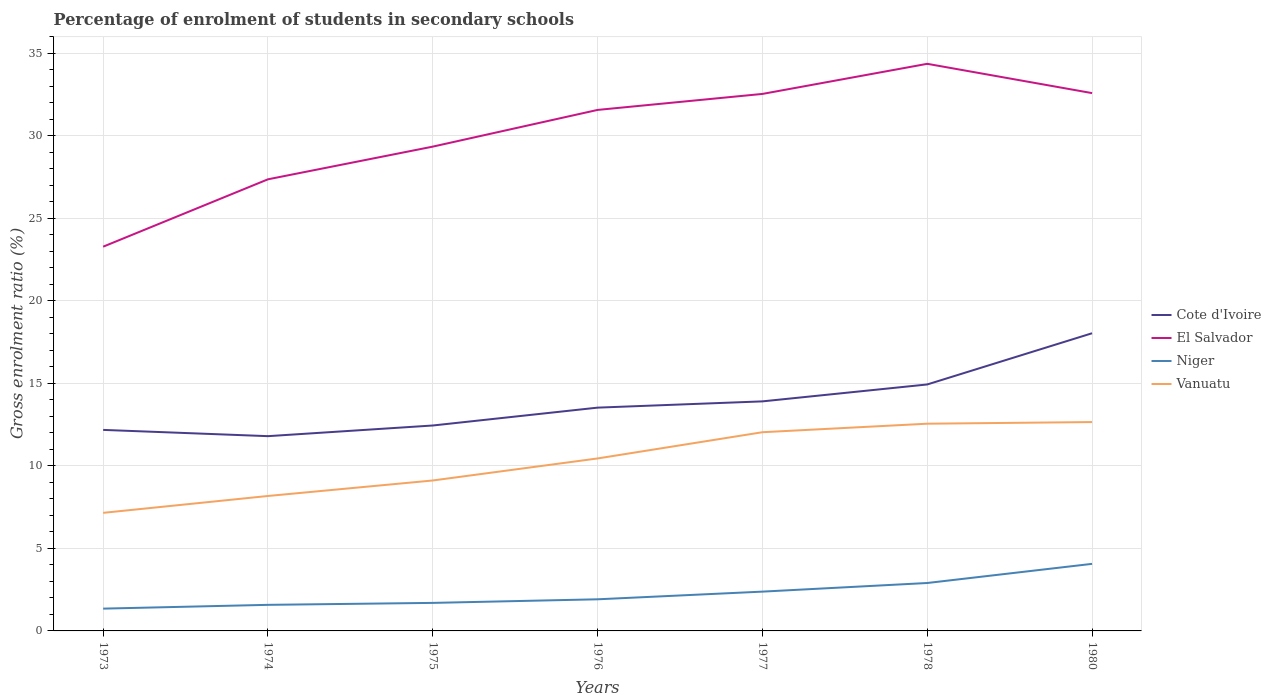How many different coloured lines are there?
Your response must be concise. 4. Is the number of lines equal to the number of legend labels?
Keep it short and to the point. Yes. Across all years, what is the maximum percentage of students enrolled in secondary schools in Vanuatu?
Your response must be concise. 7.16. In which year was the percentage of students enrolled in secondary schools in El Salvador maximum?
Make the answer very short. 1973. What is the total percentage of students enrolled in secondary schools in Niger in the graph?
Give a very brief answer. -0.57. What is the difference between the highest and the second highest percentage of students enrolled in secondary schools in Cote d'Ivoire?
Your response must be concise. 6.24. Is the percentage of students enrolled in secondary schools in Vanuatu strictly greater than the percentage of students enrolled in secondary schools in El Salvador over the years?
Your answer should be compact. Yes. Does the graph contain any zero values?
Your response must be concise. No. Does the graph contain grids?
Ensure brevity in your answer.  Yes. Where does the legend appear in the graph?
Keep it short and to the point. Center right. How many legend labels are there?
Make the answer very short. 4. How are the legend labels stacked?
Your answer should be very brief. Vertical. What is the title of the graph?
Give a very brief answer. Percentage of enrolment of students in secondary schools. Does "Northern Mariana Islands" appear as one of the legend labels in the graph?
Give a very brief answer. No. What is the Gross enrolment ratio (%) in Cote d'Ivoire in 1973?
Ensure brevity in your answer.  12.18. What is the Gross enrolment ratio (%) of El Salvador in 1973?
Give a very brief answer. 23.28. What is the Gross enrolment ratio (%) in Niger in 1973?
Give a very brief answer. 1.35. What is the Gross enrolment ratio (%) in Vanuatu in 1973?
Your response must be concise. 7.16. What is the Gross enrolment ratio (%) of Cote d'Ivoire in 1974?
Offer a terse response. 11.8. What is the Gross enrolment ratio (%) of El Salvador in 1974?
Your answer should be compact. 27.37. What is the Gross enrolment ratio (%) in Niger in 1974?
Ensure brevity in your answer.  1.58. What is the Gross enrolment ratio (%) of Vanuatu in 1974?
Your response must be concise. 8.18. What is the Gross enrolment ratio (%) in Cote d'Ivoire in 1975?
Your answer should be very brief. 12.45. What is the Gross enrolment ratio (%) of El Salvador in 1975?
Give a very brief answer. 29.35. What is the Gross enrolment ratio (%) of Niger in 1975?
Give a very brief answer. 1.7. What is the Gross enrolment ratio (%) in Vanuatu in 1975?
Your response must be concise. 9.12. What is the Gross enrolment ratio (%) of Cote d'Ivoire in 1976?
Provide a short and direct response. 13.53. What is the Gross enrolment ratio (%) in El Salvador in 1976?
Your response must be concise. 31.57. What is the Gross enrolment ratio (%) of Niger in 1976?
Provide a short and direct response. 1.92. What is the Gross enrolment ratio (%) of Vanuatu in 1976?
Your response must be concise. 10.45. What is the Gross enrolment ratio (%) in Cote d'Ivoire in 1977?
Offer a terse response. 13.91. What is the Gross enrolment ratio (%) of El Salvador in 1977?
Your answer should be very brief. 32.54. What is the Gross enrolment ratio (%) of Niger in 1977?
Offer a terse response. 2.38. What is the Gross enrolment ratio (%) of Vanuatu in 1977?
Your answer should be compact. 12.04. What is the Gross enrolment ratio (%) in Cote d'Ivoire in 1978?
Offer a terse response. 14.93. What is the Gross enrolment ratio (%) of El Salvador in 1978?
Ensure brevity in your answer.  34.36. What is the Gross enrolment ratio (%) in Niger in 1978?
Offer a very short reply. 2.9. What is the Gross enrolment ratio (%) in Vanuatu in 1978?
Provide a short and direct response. 12.56. What is the Gross enrolment ratio (%) in Cote d'Ivoire in 1980?
Offer a terse response. 18.04. What is the Gross enrolment ratio (%) in El Salvador in 1980?
Offer a terse response. 32.59. What is the Gross enrolment ratio (%) of Niger in 1980?
Your answer should be very brief. 4.06. What is the Gross enrolment ratio (%) of Vanuatu in 1980?
Your response must be concise. 12.66. Across all years, what is the maximum Gross enrolment ratio (%) of Cote d'Ivoire?
Offer a very short reply. 18.04. Across all years, what is the maximum Gross enrolment ratio (%) of El Salvador?
Your answer should be very brief. 34.36. Across all years, what is the maximum Gross enrolment ratio (%) in Niger?
Keep it short and to the point. 4.06. Across all years, what is the maximum Gross enrolment ratio (%) of Vanuatu?
Offer a very short reply. 12.66. Across all years, what is the minimum Gross enrolment ratio (%) in Cote d'Ivoire?
Make the answer very short. 11.8. Across all years, what is the minimum Gross enrolment ratio (%) of El Salvador?
Provide a short and direct response. 23.28. Across all years, what is the minimum Gross enrolment ratio (%) of Niger?
Provide a short and direct response. 1.35. Across all years, what is the minimum Gross enrolment ratio (%) in Vanuatu?
Give a very brief answer. 7.16. What is the total Gross enrolment ratio (%) of Cote d'Ivoire in the graph?
Give a very brief answer. 96.84. What is the total Gross enrolment ratio (%) of El Salvador in the graph?
Make the answer very short. 211.06. What is the total Gross enrolment ratio (%) of Niger in the graph?
Offer a very short reply. 15.9. What is the total Gross enrolment ratio (%) of Vanuatu in the graph?
Offer a very short reply. 72.15. What is the difference between the Gross enrolment ratio (%) in Cote d'Ivoire in 1973 and that in 1974?
Make the answer very short. 0.38. What is the difference between the Gross enrolment ratio (%) in El Salvador in 1973 and that in 1974?
Your answer should be compact. -4.08. What is the difference between the Gross enrolment ratio (%) of Niger in 1973 and that in 1974?
Make the answer very short. -0.23. What is the difference between the Gross enrolment ratio (%) in Vanuatu in 1973 and that in 1974?
Your answer should be very brief. -1.02. What is the difference between the Gross enrolment ratio (%) in Cote d'Ivoire in 1973 and that in 1975?
Make the answer very short. -0.27. What is the difference between the Gross enrolment ratio (%) of El Salvador in 1973 and that in 1975?
Your answer should be compact. -6.06. What is the difference between the Gross enrolment ratio (%) of Niger in 1973 and that in 1975?
Make the answer very short. -0.35. What is the difference between the Gross enrolment ratio (%) in Vanuatu in 1973 and that in 1975?
Provide a succinct answer. -1.96. What is the difference between the Gross enrolment ratio (%) in Cote d'Ivoire in 1973 and that in 1976?
Make the answer very short. -1.35. What is the difference between the Gross enrolment ratio (%) of El Salvador in 1973 and that in 1976?
Provide a short and direct response. -8.29. What is the difference between the Gross enrolment ratio (%) in Niger in 1973 and that in 1976?
Your response must be concise. -0.57. What is the difference between the Gross enrolment ratio (%) of Vanuatu in 1973 and that in 1976?
Give a very brief answer. -3.3. What is the difference between the Gross enrolment ratio (%) of Cote d'Ivoire in 1973 and that in 1977?
Keep it short and to the point. -1.73. What is the difference between the Gross enrolment ratio (%) in El Salvador in 1973 and that in 1977?
Offer a terse response. -9.26. What is the difference between the Gross enrolment ratio (%) of Niger in 1973 and that in 1977?
Your answer should be compact. -1.03. What is the difference between the Gross enrolment ratio (%) of Vanuatu in 1973 and that in 1977?
Offer a terse response. -4.88. What is the difference between the Gross enrolment ratio (%) of Cote d'Ivoire in 1973 and that in 1978?
Your answer should be compact. -2.75. What is the difference between the Gross enrolment ratio (%) of El Salvador in 1973 and that in 1978?
Your response must be concise. -11.08. What is the difference between the Gross enrolment ratio (%) in Niger in 1973 and that in 1978?
Your response must be concise. -1.55. What is the difference between the Gross enrolment ratio (%) in Vanuatu in 1973 and that in 1978?
Your response must be concise. -5.4. What is the difference between the Gross enrolment ratio (%) in Cote d'Ivoire in 1973 and that in 1980?
Keep it short and to the point. -5.86. What is the difference between the Gross enrolment ratio (%) of El Salvador in 1973 and that in 1980?
Your answer should be compact. -9.31. What is the difference between the Gross enrolment ratio (%) in Niger in 1973 and that in 1980?
Your response must be concise. -2.71. What is the difference between the Gross enrolment ratio (%) of Vanuatu in 1973 and that in 1980?
Offer a very short reply. -5.5. What is the difference between the Gross enrolment ratio (%) of Cote d'Ivoire in 1974 and that in 1975?
Keep it short and to the point. -0.65. What is the difference between the Gross enrolment ratio (%) of El Salvador in 1974 and that in 1975?
Your answer should be very brief. -1.98. What is the difference between the Gross enrolment ratio (%) of Niger in 1974 and that in 1975?
Keep it short and to the point. -0.12. What is the difference between the Gross enrolment ratio (%) of Vanuatu in 1974 and that in 1975?
Your answer should be very brief. -0.94. What is the difference between the Gross enrolment ratio (%) in Cote d'Ivoire in 1974 and that in 1976?
Offer a terse response. -1.73. What is the difference between the Gross enrolment ratio (%) in El Salvador in 1974 and that in 1976?
Offer a terse response. -4.2. What is the difference between the Gross enrolment ratio (%) of Niger in 1974 and that in 1976?
Provide a succinct answer. -0.34. What is the difference between the Gross enrolment ratio (%) of Vanuatu in 1974 and that in 1976?
Provide a short and direct response. -2.27. What is the difference between the Gross enrolment ratio (%) of Cote d'Ivoire in 1974 and that in 1977?
Keep it short and to the point. -2.11. What is the difference between the Gross enrolment ratio (%) in El Salvador in 1974 and that in 1977?
Provide a short and direct response. -5.17. What is the difference between the Gross enrolment ratio (%) in Niger in 1974 and that in 1977?
Your response must be concise. -0.8. What is the difference between the Gross enrolment ratio (%) in Vanuatu in 1974 and that in 1977?
Keep it short and to the point. -3.86. What is the difference between the Gross enrolment ratio (%) in Cote d'Ivoire in 1974 and that in 1978?
Offer a very short reply. -3.13. What is the difference between the Gross enrolment ratio (%) of El Salvador in 1974 and that in 1978?
Offer a terse response. -7. What is the difference between the Gross enrolment ratio (%) in Niger in 1974 and that in 1978?
Offer a terse response. -1.32. What is the difference between the Gross enrolment ratio (%) of Vanuatu in 1974 and that in 1978?
Your response must be concise. -4.38. What is the difference between the Gross enrolment ratio (%) of Cote d'Ivoire in 1974 and that in 1980?
Ensure brevity in your answer.  -6.24. What is the difference between the Gross enrolment ratio (%) of El Salvador in 1974 and that in 1980?
Provide a short and direct response. -5.22. What is the difference between the Gross enrolment ratio (%) in Niger in 1974 and that in 1980?
Provide a short and direct response. -2.48. What is the difference between the Gross enrolment ratio (%) in Vanuatu in 1974 and that in 1980?
Your answer should be very brief. -4.48. What is the difference between the Gross enrolment ratio (%) of Cote d'Ivoire in 1975 and that in 1976?
Keep it short and to the point. -1.08. What is the difference between the Gross enrolment ratio (%) in El Salvador in 1975 and that in 1976?
Give a very brief answer. -2.22. What is the difference between the Gross enrolment ratio (%) of Niger in 1975 and that in 1976?
Provide a short and direct response. -0.22. What is the difference between the Gross enrolment ratio (%) of Vanuatu in 1975 and that in 1976?
Make the answer very short. -1.33. What is the difference between the Gross enrolment ratio (%) of Cote d'Ivoire in 1975 and that in 1977?
Provide a short and direct response. -1.46. What is the difference between the Gross enrolment ratio (%) in El Salvador in 1975 and that in 1977?
Your response must be concise. -3.19. What is the difference between the Gross enrolment ratio (%) of Niger in 1975 and that in 1977?
Ensure brevity in your answer.  -0.68. What is the difference between the Gross enrolment ratio (%) of Vanuatu in 1975 and that in 1977?
Give a very brief answer. -2.92. What is the difference between the Gross enrolment ratio (%) of Cote d'Ivoire in 1975 and that in 1978?
Ensure brevity in your answer.  -2.49. What is the difference between the Gross enrolment ratio (%) in El Salvador in 1975 and that in 1978?
Offer a very short reply. -5.02. What is the difference between the Gross enrolment ratio (%) in Niger in 1975 and that in 1978?
Give a very brief answer. -1.21. What is the difference between the Gross enrolment ratio (%) in Vanuatu in 1975 and that in 1978?
Provide a succinct answer. -3.44. What is the difference between the Gross enrolment ratio (%) in Cote d'Ivoire in 1975 and that in 1980?
Give a very brief answer. -5.59. What is the difference between the Gross enrolment ratio (%) of El Salvador in 1975 and that in 1980?
Ensure brevity in your answer.  -3.24. What is the difference between the Gross enrolment ratio (%) in Niger in 1975 and that in 1980?
Offer a very short reply. -2.37. What is the difference between the Gross enrolment ratio (%) of Vanuatu in 1975 and that in 1980?
Provide a short and direct response. -3.54. What is the difference between the Gross enrolment ratio (%) in Cote d'Ivoire in 1976 and that in 1977?
Provide a short and direct response. -0.38. What is the difference between the Gross enrolment ratio (%) of El Salvador in 1976 and that in 1977?
Offer a very short reply. -0.97. What is the difference between the Gross enrolment ratio (%) of Niger in 1976 and that in 1977?
Keep it short and to the point. -0.46. What is the difference between the Gross enrolment ratio (%) of Vanuatu in 1976 and that in 1977?
Ensure brevity in your answer.  -1.59. What is the difference between the Gross enrolment ratio (%) in Cote d'Ivoire in 1976 and that in 1978?
Offer a very short reply. -1.4. What is the difference between the Gross enrolment ratio (%) of El Salvador in 1976 and that in 1978?
Your answer should be very brief. -2.79. What is the difference between the Gross enrolment ratio (%) in Niger in 1976 and that in 1978?
Give a very brief answer. -0.99. What is the difference between the Gross enrolment ratio (%) in Vanuatu in 1976 and that in 1978?
Your answer should be very brief. -2.11. What is the difference between the Gross enrolment ratio (%) in Cote d'Ivoire in 1976 and that in 1980?
Your response must be concise. -4.51. What is the difference between the Gross enrolment ratio (%) of El Salvador in 1976 and that in 1980?
Make the answer very short. -1.02. What is the difference between the Gross enrolment ratio (%) in Niger in 1976 and that in 1980?
Keep it short and to the point. -2.15. What is the difference between the Gross enrolment ratio (%) in Vanuatu in 1976 and that in 1980?
Your answer should be compact. -2.2. What is the difference between the Gross enrolment ratio (%) of Cote d'Ivoire in 1977 and that in 1978?
Give a very brief answer. -1.02. What is the difference between the Gross enrolment ratio (%) of El Salvador in 1977 and that in 1978?
Offer a terse response. -1.82. What is the difference between the Gross enrolment ratio (%) in Niger in 1977 and that in 1978?
Keep it short and to the point. -0.52. What is the difference between the Gross enrolment ratio (%) in Vanuatu in 1977 and that in 1978?
Provide a short and direct response. -0.52. What is the difference between the Gross enrolment ratio (%) of Cote d'Ivoire in 1977 and that in 1980?
Give a very brief answer. -4.13. What is the difference between the Gross enrolment ratio (%) in El Salvador in 1977 and that in 1980?
Provide a short and direct response. -0.05. What is the difference between the Gross enrolment ratio (%) of Niger in 1977 and that in 1980?
Offer a terse response. -1.68. What is the difference between the Gross enrolment ratio (%) of Vanuatu in 1977 and that in 1980?
Offer a terse response. -0.62. What is the difference between the Gross enrolment ratio (%) in Cote d'Ivoire in 1978 and that in 1980?
Your answer should be very brief. -3.1. What is the difference between the Gross enrolment ratio (%) in El Salvador in 1978 and that in 1980?
Your response must be concise. 1.78. What is the difference between the Gross enrolment ratio (%) in Niger in 1978 and that in 1980?
Your answer should be very brief. -1.16. What is the difference between the Gross enrolment ratio (%) in Vanuatu in 1978 and that in 1980?
Offer a terse response. -0.1. What is the difference between the Gross enrolment ratio (%) in Cote d'Ivoire in 1973 and the Gross enrolment ratio (%) in El Salvador in 1974?
Provide a short and direct response. -15.18. What is the difference between the Gross enrolment ratio (%) in Cote d'Ivoire in 1973 and the Gross enrolment ratio (%) in Niger in 1974?
Make the answer very short. 10.6. What is the difference between the Gross enrolment ratio (%) in Cote d'Ivoire in 1973 and the Gross enrolment ratio (%) in Vanuatu in 1974?
Your answer should be compact. 4. What is the difference between the Gross enrolment ratio (%) in El Salvador in 1973 and the Gross enrolment ratio (%) in Niger in 1974?
Your answer should be compact. 21.7. What is the difference between the Gross enrolment ratio (%) of El Salvador in 1973 and the Gross enrolment ratio (%) of Vanuatu in 1974?
Give a very brief answer. 15.11. What is the difference between the Gross enrolment ratio (%) of Niger in 1973 and the Gross enrolment ratio (%) of Vanuatu in 1974?
Provide a succinct answer. -6.83. What is the difference between the Gross enrolment ratio (%) of Cote d'Ivoire in 1973 and the Gross enrolment ratio (%) of El Salvador in 1975?
Your answer should be compact. -17.16. What is the difference between the Gross enrolment ratio (%) of Cote d'Ivoire in 1973 and the Gross enrolment ratio (%) of Niger in 1975?
Make the answer very short. 10.48. What is the difference between the Gross enrolment ratio (%) in Cote d'Ivoire in 1973 and the Gross enrolment ratio (%) in Vanuatu in 1975?
Give a very brief answer. 3.06. What is the difference between the Gross enrolment ratio (%) in El Salvador in 1973 and the Gross enrolment ratio (%) in Niger in 1975?
Make the answer very short. 21.58. What is the difference between the Gross enrolment ratio (%) in El Salvador in 1973 and the Gross enrolment ratio (%) in Vanuatu in 1975?
Give a very brief answer. 14.17. What is the difference between the Gross enrolment ratio (%) of Niger in 1973 and the Gross enrolment ratio (%) of Vanuatu in 1975?
Make the answer very short. -7.77. What is the difference between the Gross enrolment ratio (%) in Cote d'Ivoire in 1973 and the Gross enrolment ratio (%) in El Salvador in 1976?
Your answer should be very brief. -19.39. What is the difference between the Gross enrolment ratio (%) in Cote d'Ivoire in 1973 and the Gross enrolment ratio (%) in Niger in 1976?
Your answer should be compact. 10.26. What is the difference between the Gross enrolment ratio (%) of Cote d'Ivoire in 1973 and the Gross enrolment ratio (%) of Vanuatu in 1976?
Offer a very short reply. 1.73. What is the difference between the Gross enrolment ratio (%) in El Salvador in 1973 and the Gross enrolment ratio (%) in Niger in 1976?
Your answer should be very brief. 21.37. What is the difference between the Gross enrolment ratio (%) of El Salvador in 1973 and the Gross enrolment ratio (%) of Vanuatu in 1976?
Your answer should be very brief. 12.83. What is the difference between the Gross enrolment ratio (%) of Niger in 1973 and the Gross enrolment ratio (%) of Vanuatu in 1976?
Your answer should be compact. -9.1. What is the difference between the Gross enrolment ratio (%) in Cote d'Ivoire in 1973 and the Gross enrolment ratio (%) in El Salvador in 1977?
Give a very brief answer. -20.36. What is the difference between the Gross enrolment ratio (%) of Cote d'Ivoire in 1973 and the Gross enrolment ratio (%) of Niger in 1977?
Your answer should be very brief. 9.8. What is the difference between the Gross enrolment ratio (%) of Cote d'Ivoire in 1973 and the Gross enrolment ratio (%) of Vanuatu in 1977?
Your answer should be very brief. 0.14. What is the difference between the Gross enrolment ratio (%) of El Salvador in 1973 and the Gross enrolment ratio (%) of Niger in 1977?
Ensure brevity in your answer.  20.9. What is the difference between the Gross enrolment ratio (%) of El Salvador in 1973 and the Gross enrolment ratio (%) of Vanuatu in 1977?
Keep it short and to the point. 11.24. What is the difference between the Gross enrolment ratio (%) of Niger in 1973 and the Gross enrolment ratio (%) of Vanuatu in 1977?
Keep it short and to the point. -10.69. What is the difference between the Gross enrolment ratio (%) of Cote d'Ivoire in 1973 and the Gross enrolment ratio (%) of El Salvador in 1978?
Give a very brief answer. -22.18. What is the difference between the Gross enrolment ratio (%) of Cote d'Ivoire in 1973 and the Gross enrolment ratio (%) of Niger in 1978?
Provide a succinct answer. 9.28. What is the difference between the Gross enrolment ratio (%) of Cote d'Ivoire in 1973 and the Gross enrolment ratio (%) of Vanuatu in 1978?
Provide a succinct answer. -0.38. What is the difference between the Gross enrolment ratio (%) of El Salvador in 1973 and the Gross enrolment ratio (%) of Niger in 1978?
Your answer should be compact. 20.38. What is the difference between the Gross enrolment ratio (%) of El Salvador in 1973 and the Gross enrolment ratio (%) of Vanuatu in 1978?
Give a very brief answer. 10.73. What is the difference between the Gross enrolment ratio (%) in Niger in 1973 and the Gross enrolment ratio (%) in Vanuatu in 1978?
Give a very brief answer. -11.21. What is the difference between the Gross enrolment ratio (%) of Cote d'Ivoire in 1973 and the Gross enrolment ratio (%) of El Salvador in 1980?
Provide a short and direct response. -20.41. What is the difference between the Gross enrolment ratio (%) in Cote d'Ivoire in 1973 and the Gross enrolment ratio (%) in Niger in 1980?
Provide a succinct answer. 8.12. What is the difference between the Gross enrolment ratio (%) of Cote d'Ivoire in 1973 and the Gross enrolment ratio (%) of Vanuatu in 1980?
Your response must be concise. -0.47. What is the difference between the Gross enrolment ratio (%) of El Salvador in 1973 and the Gross enrolment ratio (%) of Niger in 1980?
Your response must be concise. 19.22. What is the difference between the Gross enrolment ratio (%) in El Salvador in 1973 and the Gross enrolment ratio (%) in Vanuatu in 1980?
Ensure brevity in your answer.  10.63. What is the difference between the Gross enrolment ratio (%) in Niger in 1973 and the Gross enrolment ratio (%) in Vanuatu in 1980?
Make the answer very short. -11.3. What is the difference between the Gross enrolment ratio (%) in Cote d'Ivoire in 1974 and the Gross enrolment ratio (%) in El Salvador in 1975?
Provide a short and direct response. -17.54. What is the difference between the Gross enrolment ratio (%) in Cote d'Ivoire in 1974 and the Gross enrolment ratio (%) in Niger in 1975?
Provide a succinct answer. 10.1. What is the difference between the Gross enrolment ratio (%) in Cote d'Ivoire in 1974 and the Gross enrolment ratio (%) in Vanuatu in 1975?
Make the answer very short. 2.69. What is the difference between the Gross enrolment ratio (%) of El Salvador in 1974 and the Gross enrolment ratio (%) of Niger in 1975?
Make the answer very short. 25.67. What is the difference between the Gross enrolment ratio (%) in El Salvador in 1974 and the Gross enrolment ratio (%) in Vanuatu in 1975?
Make the answer very short. 18.25. What is the difference between the Gross enrolment ratio (%) of Niger in 1974 and the Gross enrolment ratio (%) of Vanuatu in 1975?
Make the answer very short. -7.54. What is the difference between the Gross enrolment ratio (%) of Cote d'Ivoire in 1974 and the Gross enrolment ratio (%) of El Salvador in 1976?
Your answer should be very brief. -19.77. What is the difference between the Gross enrolment ratio (%) in Cote d'Ivoire in 1974 and the Gross enrolment ratio (%) in Niger in 1976?
Provide a short and direct response. 9.88. What is the difference between the Gross enrolment ratio (%) of Cote d'Ivoire in 1974 and the Gross enrolment ratio (%) of Vanuatu in 1976?
Give a very brief answer. 1.35. What is the difference between the Gross enrolment ratio (%) of El Salvador in 1974 and the Gross enrolment ratio (%) of Niger in 1976?
Ensure brevity in your answer.  25.45. What is the difference between the Gross enrolment ratio (%) in El Salvador in 1974 and the Gross enrolment ratio (%) in Vanuatu in 1976?
Your response must be concise. 16.91. What is the difference between the Gross enrolment ratio (%) of Niger in 1974 and the Gross enrolment ratio (%) of Vanuatu in 1976?
Your answer should be very brief. -8.87. What is the difference between the Gross enrolment ratio (%) in Cote d'Ivoire in 1974 and the Gross enrolment ratio (%) in El Salvador in 1977?
Your response must be concise. -20.74. What is the difference between the Gross enrolment ratio (%) in Cote d'Ivoire in 1974 and the Gross enrolment ratio (%) in Niger in 1977?
Offer a terse response. 9.42. What is the difference between the Gross enrolment ratio (%) of Cote d'Ivoire in 1974 and the Gross enrolment ratio (%) of Vanuatu in 1977?
Your answer should be very brief. -0.24. What is the difference between the Gross enrolment ratio (%) in El Salvador in 1974 and the Gross enrolment ratio (%) in Niger in 1977?
Your answer should be very brief. 24.98. What is the difference between the Gross enrolment ratio (%) in El Salvador in 1974 and the Gross enrolment ratio (%) in Vanuatu in 1977?
Offer a very short reply. 15.33. What is the difference between the Gross enrolment ratio (%) of Niger in 1974 and the Gross enrolment ratio (%) of Vanuatu in 1977?
Your response must be concise. -10.46. What is the difference between the Gross enrolment ratio (%) in Cote d'Ivoire in 1974 and the Gross enrolment ratio (%) in El Salvador in 1978?
Give a very brief answer. -22.56. What is the difference between the Gross enrolment ratio (%) of Cote d'Ivoire in 1974 and the Gross enrolment ratio (%) of Niger in 1978?
Make the answer very short. 8.9. What is the difference between the Gross enrolment ratio (%) of Cote d'Ivoire in 1974 and the Gross enrolment ratio (%) of Vanuatu in 1978?
Make the answer very short. -0.75. What is the difference between the Gross enrolment ratio (%) in El Salvador in 1974 and the Gross enrolment ratio (%) in Niger in 1978?
Offer a very short reply. 24.46. What is the difference between the Gross enrolment ratio (%) in El Salvador in 1974 and the Gross enrolment ratio (%) in Vanuatu in 1978?
Your response must be concise. 14.81. What is the difference between the Gross enrolment ratio (%) of Niger in 1974 and the Gross enrolment ratio (%) of Vanuatu in 1978?
Offer a terse response. -10.98. What is the difference between the Gross enrolment ratio (%) in Cote d'Ivoire in 1974 and the Gross enrolment ratio (%) in El Salvador in 1980?
Offer a terse response. -20.79. What is the difference between the Gross enrolment ratio (%) of Cote d'Ivoire in 1974 and the Gross enrolment ratio (%) of Niger in 1980?
Your answer should be very brief. 7.74. What is the difference between the Gross enrolment ratio (%) of Cote d'Ivoire in 1974 and the Gross enrolment ratio (%) of Vanuatu in 1980?
Your answer should be compact. -0.85. What is the difference between the Gross enrolment ratio (%) in El Salvador in 1974 and the Gross enrolment ratio (%) in Niger in 1980?
Provide a short and direct response. 23.3. What is the difference between the Gross enrolment ratio (%) in El Salvador in 1974 and the Gross enrolment ratio (%) in Vanuatu in 1980?
Make the answer very short. 14.71. What is the difference between the Gross enrolment ratio (%) of Niger in 1974 and the Gross enrolment ratio (%) of Vanuatu in 1980?
Your response must be concise. -11.08. What is the difference between the Gross enrolment ratio (%) in Cote d'Ivoire in 1975 and the Gross enrolment ratio (%) in El Salvador in 1976?
Provide a succinct answer. -19.12. What is the difference between the Gross enrolment ratio (%) in Cote d'Ivoire in 1975 and the Gross enrolment ratio (%) in Niger in 1976?
Provide a succinct answer. 10.53. What is the difference between the Gross enrolment ratio (%) in Cote d'Ivoire in 1975 and the Gross enrolment ratio (%) in Vanuatu in 1976?
Ensure brevity in your answer.  2. What is the difference between the Gross enrolment ratio (%) in El Salvador in 1975 and the Gross enrolment ratio (%) in Niger in 1976?
Offer a terse response. 27.43. What is the difference between the Gross enrolment ratio (%) in El Salvador in 1975 and the Gross enrolment ratio (%) in Vanuatu in 1976?
Provide a short and direct response. 18.89. What is the difference between the Gross enrolment ratio (%) in Niger in 1975 and the Gross enrolment ratio (%) in Vanuatu in 1976?
Give a very brief answer. -8.75. What is the difference between the Gross enrolment ratio (%) in Cote d'Ivoire in 1975 and the Gross enrolment ratio (%) in El Salvador in 1977?
Keep it short and to the point. -20.09. What is the difference between the Gross enrolment ratio (%) of Cote d'Ivoire in 1975 and the Gross enrolment ratio (%) of Niger in 1977?
Offer a terse response. 10.07. What is the difference between the Gross enrolment ratio (%) in Cote d'Ivoire in 1975 and the Gross enrolment ratio (%) in Vanuatu in 1977?
Ensure brevity in your answer.  0.41. What is the difference between the Gross enrolment ratio (%) in El Salvador in 1975 and the Gross enrolment ratio (%) in Niger in 1977?
Your response must be concise. 26.96. What is the difference between the Gross enrolment ratio (%) in El Salvador in 1975 and the Gross enrolment ratio (%) in Vanuatu in 1977?
Your answer should be very brief. 17.31. What is the difference between the Gross enrolment ratio (%) of Niger in 1975 and the Gross enrolment ratio (%) of Vanuatu in 1977?
Keep it short and to the point. -10.34. What is the difference between the Gross enrolment ratio (%) of Cote d'Ivoire in 1975 and the Gross enrolment ratio (%) of El Salvador in 1978?
Your answer should be compact. -21.92. What is the difference between the Gross enrolment ratio (%) of Cote d'Ivoire in 1975 and the Gross enrolment ratio (%) of Niger in 1978?
Ensure brevity in your answer.  9.54. What is the difference between the Gross enrolment ratio (%) in Cote d'Ivoire in 1975 and the Gross enrolment ratio (%) in Vanuatu in 1978?
Give a very brief answer. -0.11. What is the difference between the Gross enrolment ratio (%) of El Salvador in 1975 and the Gross enrolment ratio (%) of Niger in 1978?
Your answer should be compact. 26.44. What is the difference between the Gross enrolment ratio (%) of El Salvador in 1975 and the Gross enrolment ratio (%) of Vanuatu in 1978?
Offer a terse response. 16.79. What is the difference between the Gross enrolment ratio (%) of Niger in 1975 and the Gross enrolment ratio (%) of Vanuatu in 1978?
Your answer should be compact. -10.86. What is the difference between the Gross enrolment ratio (%) in Cote d'Ivoire in 1975 and the Gross enrolment ratio (%) in El Salvador in 1980?
Give a very brief answer. -20.14. What is the difference between the Gross enrolment ratio (%) of Cote d'Ivoire in 1975 and the Gross enrolment ratio (%) of Niger in 1980?
Your response must be concise. 8.38. What is the difference between the Gross enrolment ratio (%) of Cote d'Ivoire in 1975 and the Gross enrolment ratio (%) of Vanuatu in 1980?
Ensure brevity in your answer.  -0.21. What is the difference between the Gross enrolment ratio (%) of El Salvador in 1975 and the Gross enrolment ratio (%) of Niger in 1980?
Provide a succinct answer. 25.28. What is the difference between the Gross enrolment ratio (%) in El Salvador in 1975 and the Gross enrolment ratio (%) in Vanuatu in 1980?
Offer a terse response. 16.69. What is the difference between the Gross enrolment ratio (%) in Niger in 1975 and the Gross enrolment ratio (%) in Vanuatu in 1980?
Keep it short and to the point. -10.96. What is the difference between the Gross enrolment ratio (%) of Cote d'Ivoire in 1976 and the Gross enrolment ratio (%) of El Salvador in 1977?
Provide a short and direct response. -19.01. What is the difference between the Gross enrolment ratio (%) in Cote d'Ivoire in 1976 and the Gross enrolment ratio (%) in Niger in 1977?
Offer a very short reply. 11.15. What is the difference between the Gross enrolment ratio (%) in Cote d'Ivoire in 1976 and the Gross enrolment ratio (%) in Vanuatu in 1977?
Offer a very short reply. 1.49. What is the difference between the Gross enrolment ratio (%) in El Salvador in 1976 and the Gross enrolment ratio (%) in Niger in 1977?
Give a very brief answer. 29.19. What is the difference between the Gross enrolment ratio (%) in El Salvador in 1976 and the Gross enrolment ratio (%) in Vanuatu in 1977?
Offer a very short reply. 19.53. What is the difference between the Gross enrolment ratio (%) of Niger in 1976 and the Gross enrolment ratio (%) of Vanuatu in 1977?
Offer a very short reply. -10.12. What is the difference between the Gross enrolment ratio (%) in Cote d'Ivoire in 1976 and the Gross enrolment ratio (%) in El Salvador in 1978?
Make the answer very short. -20.83. What is the difference between the Gross enrolment ratio (%) in Cote d'Ivoire in 1976 and the Gross enrolment ratio (%) in Niger in 1978?
Keep it short and to the point. 10.63. What is the difference between the Gross enrolment ratio (%) of Cote d'Ivoire in 1976 and the Gross enrolment ratio (%) of Vanuatu in 1978?
Provide a succinct answer. 0.97. What is the difference between the Gross enrolment ratio (%) of El Salvador in 1976 and the Gross enrolment ratio (%) of Niger in 1978?
Your answer should be very brief. 28.67. What is the difference between the Gross enrolment ratio (%) of El Salvador in 1976 and the Gross enrolment ratio (%) of Vanuatu in 1978?
Your response must be concise. 19.01. What is the difference between the Gross enrolment ratio (%) in Niger in 1976 and the Gross enrolment ratio (%) in Vanuatu in 1978?
Offer a very short reply. -10.64. What is the difference between the Gross enrolment ratio (%) in Cote d'Ivoire in 1976 and the Gross enrolment ratio (%) in El Salvador in 1980?
Make the answer very short. -19.06. What is the difference between the Gross enrolment ratio (%) in Cote d'Ivoire in 1976 and the Gross enrolment ratio (%) in Niger in 1980?
Your response must be concise. 9.47. What is the difference between the Gross enrolment ratio (%) of Cote d'Ivoire in 1976 and the Gross enrolment ratio (%) of Vanuatu in 1980?
Your answer should be compact. 0.87. What is the difference between the Gross enrolment ratio (%) in El Salvador in 1976 and the Gross enrolment ratio (%) in Niger in 1980?
Your response must be concise. 27.51. What is the difference between the Gross enrolment ratio (%) in El Salvador in 1976 and the Gross enrolment ratio (%) in Vanuatu in 1980?
Make the answer very short. 18.91. What is the difference between the Gross enrolment ratio (%) in Niger in 1976 and the Gross enrolment ratio (%) in Vanuatu in 1980?
Provide a short and direct response. -10.74. What is the difference between the Gross enrolment ratio (%) in Cote d'Ivoire in 1977 and the Gross enrolment ratio (%) in El Salvador in 1978?
Your answer should be very brief. -20.45. What is the difference between the Gross enrolment ratio (%) of Cote d'Ivoire in 1977 and the Gross enrolment ratio (%) of Niger in 1978?
Ensure brevity in your answer.  11.01. What is the difference between the Gross enrolment ratio (%) in Cote d'Ivoire in 1977 and the Gross enrolment ratio (%) in Vanuatu in 1978?
Ensure brevity in your answer.  1.35. What is the difference between the Gross enrolment ratio (%) of El Salvador in 1977 and the Gross enrolment ratio (%) of Niger in 1978?
Offer a terse response. 29.64. What is the difference between the Gross enrolment ratio (%) in El Salvador in 1977 and the Gross enrolment ratio (%) in Vanuatu in 1978?
Offer a terse response. 19.98. What is the difference between the Gross enrolment ratio (%) of Niger in 1977 and the Gross enrolment ratio (%) of Vanuatu in 1978?
Your answer should be very brief. -10.18. What is the difference between the Gross enrolment ratio (%) in Cote d'Ivoire in 1977 and the Gross enrolment ratio (%) in El Salvador in 1980?
Your response must be concise. -18.68. What is the difference between the Gross enrolment ratio (%) in Cote d'Ivoire in 1977 and the Gross enrolment ratio (%) in Niger in 1980?
Offer a very short reply. 9.85. What is the difference between the Gross enrolment ratio (%) in Cote d'Ivoire in 1977 and the Gross enrolment ratio (%) in Vanuatu in 1980?
Keep it short and to the point. 1.25. What is the difference between the Gross enrolment ratio (%) of El Salvador in 1977 and the Gross enrolment ratio (%) of Niger in 1980?
Give a very brief answer. 28.47. What is the difference between the Gross enrolment ratio (%) of El Salvador in 1977 and the Gross enrolment ratio (%) of Vanuatu in 1980?
Ensure brevity in your answer.  19.88. What is the difference between the Gross enrolment ratio (%) of Niger in 1977 and the Gross enrolment ratio (%) of Vanuatu in 1980?
Ensure brevity in your answer.  -10.27. What is the difference between the Gross enrolment ratio (%) of Cote d'Ivoire in 1978 and the Gross enrolment ratio (%) of El Salvador in 1980?
Your answer should be very brief. -17.65. What is the difference between the Gross enrolment ratio (%) in Cote d'Ivoire in 1978 and the Gross enrolment ratio (%) in Niger in 1980?
Provide a short and direct response. 10.87. What is the difference between the Gross enrolment ratio (%) in Cote d'Ivoire in 1978 and the Gross enrolment ratio (%) in Vanuatu in 1980?
Provide a succinct answer. 2.28. What is the difference between the Gross enrolment ratio (%) in El Salvador in 1978 and the Gross enrolment ratio (%) in Niger in 1980?
Ensure brevity in your answer.  30.3. What is the difference between the Gross enrolment ratio (%) of El Salvador in 1978 and the Gross enrolment ratio (%) of Vanuatu in 1980?
Offer a very short reply. 21.71. What is the difference between the Gross enrolment ratio (%) in Niger in 1978 and the Gross enrolment ratio (%) in Vanuatu in 1980?
Give a very brief answer. -9.75. What is the average Gross enrolment ratio (%) in Cote d'Ivoire per year?
Make the answer very short. 13.83. What is the average Gross enrolment ratio (%) of El Salvador per year?
Your response must be concise. 30.15. What is the average Gross enrolment ratio (%) of Niger per year?
Your answer should be very brief. 2.27. What is the average Gross enrolment ratio (%) in Vanuatu per year?
Ensure brevity in your answer.  10.31. In the year 1973, what is the difference between the Gross enrolment ratio (%) in Cote d'Ivoire and Gross enrolment ratio (%) in El Salvador?
Offer a very short reply. -11.1. In the year 1973, what is the difference between the Gross enrolment ratio (%) in Cote d'Ivoire and Gross enrolment ratio (%) in Niger?
Provide a short and direct response. 10.83. In the year 1973, what is the difference between the Gross enrolment ratio (%) in Cote d'Ivoire and Gross enrolment ratio (%) in Vanuatu?
Make the answer very short. 5.03. In the year 1973, what is the difference between the Gross enrolment ratio (%) of El Salvador and Gross enrolment ratio (%) of Niger?
Offer a very short reply. 21.93. In the year 1973, what is the difference between the Gross enrolment ratio (%) of El Salvador and Gross enrolment ratio (%) of Vanuatu?
Make the answer very short. 16.13. In the year 1973, what is the difference between the Gross enrolment ratio (%) in Niger and Gross enrolment ratio (%) in Vanuatu?
Your response must be concise. -5.8. In the year 1974, what is the difference between the Gross enrolment ratio (%) in Cote d'Ivoire and Gross enrolment ratio (%) in El Salvador?
Provide a short and direct response. -15.56. In the year 1974, what is the difference between the Gross enrolment ratio (%) of Cote d'Ivoire and Gross enrolment ratio (%) of Niger?
Make the answer very short. 10.22. In the year 1974, what is the difference between the Gross enrolment ratio (%) of Cote d'Ivoire and Gross enrolment ratio (%) of Vanuatu?
Provide a short and direct response. 3.62. In the year 1974, what is the difference between the Gross enrolment ratio (%) in El Salvador and Gross enrolment ratio (%) in Niger?
Provide a short and direct response. 25.79. In the year 1974, what is the difference between the Gross enrolment ratio (%) of El Salvador and Gross enrolment ratio (%) of Vanuatu?
Make the answer very short. 19.19. In the year 1974, what is the difference between the Gross enrolment ratio (%) of Niger and Gross enrolment ratio (%) of Vanuatu?
Make the answer very short. -6.6. In the year 1975, what is the difference between the Gross enrolment ratio (%) of Cote d'Ivoire and Gross enrolment ratio (%) of El Salvador?
Your answer should be very brief. -16.9. In the year 1975, what is the difference between the Gross enrolment ratio (%) of Cote d'Ivoire and Gross enrolment ratio (%) of Niger?
Your answer should be very brief. 10.75. In the year 1975, what is the difference between the Gross enrolment ratio (%) in Cote d'Ivoire and Gross enrolment ratio (%) in Vanuatu?
Provide a succinct answer. 3.33. In the year 1975, what is the difference between the Gross enrolment ratio (%) of El Salvador and Gross enrolment ratio (%) of Niger?
Ensure brevity in your answer.  27.65. In the year 1975, what is the difference between the Gross enrolment ratio (%) of El Salvador and Gross enrolment ratio (%) of Vanuatu?
Keep it short and to the point. 20.23. In the year 1975, what is the difference between the Gross enrolment ratio (%) in Niger and Gross enrolment ratio (%) in Vanuatu?
Keep it short and to the point. -7.42. In the year 1976, what is the difference between the Gross enrolment ratio (%) in Cote d'Ivoire and Gross enrolment ratio (%) in El Salvador?
Provide a short and direct response. -18.04. In the year 1976, what is the difference between the Gross enrolment ratio (%) of Cote d'Ivoire and Gross enrolment ratio (%) of Niger?
Provide a short and direct response. 11.61. In the year 1976, what is the difference between the Gross enrolment ratio (%) of Cote d'Ivoire and Gross enrolment ratio (%) of Vanuatu?
Keep it short and to the point. 3.08. In the year 1976, what is the difference between the Gross enrolment ratio (%) in El Salvador and Gross enrolment ratio (%) in Niger?
Ensure brevity in your answer.  29.65. In the year 1976, what is the difference between the Gross enrolment ratio (%) in El Salvador and Gross enrolment ratio (%) in Vanuatu?
Provide a short and direct response. 21.12. In the year 1976, what is the difference between the Gross enrolment ratio (%) in Niger and Gross enrolment ratio (%) in Vanuatu?
Keep it short and to the point. -8.53. In the year 1977, what is the difference between the Gross enrolment ratio (%) of Cote d'Ivoire and Gross enrolment ratio (%) of El Salvador?
Your answer should be compact. -18.63. In the year 1977, what is the difference between the Gross enrolment ratio (%) of Cote d'Ivoire and Gross enrolment ratio (%) of Niger?
Offer a very short reply. 11.53. In the year 1977, what is the difference between the Gross enrolment ratio (%) of Cote d'Ivoire and Gross enrolment ratio (%) of Vanuatu?
Offer a terse response. 1.87. In the year 1977, what is the difference between the Gross enrolment ratio (%) in El Salvador and Gross enrolment ratio (%) in Niger?
Ensure brevity in your answer.  30.16. In the year 1977, what is the difference between the Gross enrolment ratio (%) in El Salvador and Gross enrolment ratio (%) in Vanuatu?
Provide a succinct answer. 20.5. In the year 1977, what is the difference between the Gross enrolment ratio (%) of Niger and Gross enrolment ratio (%) of Vanuatu?
Your answer should be compact. -9.66. In the year 1978, what is the difference between the Gross enrolment ratio (%) of Cote d'Ivoire and Gross enrolment ratio (%) of El Salvador?
Keep it short and to the point. -19.43. In the year 1978, what is the difference between the Gross enrolment ratio (%) in Cote d'Ivoire and Gross enrolment ratio (%) in Niger?
Your response must be concise. 12.03. In the year 1978, what is the difference between the Gross enrolment ratio (%) in Cote d'Ivoire and Gross enrolment ratio (%) in Vanuatu?
Your answer should be very brief. 2.38. In the year 1978, what is the difference between the Gross enrolment ratio (%) of El Salvador and Gross enrolment ratio (%) of Niger?
Ensure brevity in your answer.  31.46. In the year 1978, what is the difference between the Gross enrolment ratio (%) in El Salvador and Gross enrolment ratio (%) in Vanuatu?
Your response must be concise. 21.81. In the year 1978, what is the difference between the Gross enrolment ratio (%) of Niger and Gross enrolment ratio (%) of Vanuatu?
Provide a succinct answer. -9.65. In the year 1980, what is the difference between the Gross enrolment ratio (%) in Cote d'Ivoire and Gross enrolment ratio (%) in El Salvador?
Your answer should be very brief. -14.55. In the year 1980, what is the difference between the Gross enrolment ratio (%) of Cote d'Ivoire and Gross enrolment ratio (%) of Niger?
Your answer should be compact. 13.97. In the year 1980, what is the difference between the Gross enrolment ratio (%) of Cote d'Ivoire and Gross enrolment ratio (%) of Vanuatu?
Provide a short and direct response. 5.38. In the year 1980, what is the difference between the Gross enrolment ratio (%) in El Salvador and Gross enrolment ratio (%) in Niger?
Make the answer very short. 28.52. In the year 1980, what is the difference between the Gross enrolment ratio (%) of El Salvador and Gross enrolment ratio (%) of Vanuatu?
Offer a very short reply. 19.93. In the year 1980, what is the difference between the Gross enrolment ratio (%) in Niger and Gross enrolment ratio (%) in Vanuatu?
Offer a very short reply. -8.59. What is the ratio of the Gross enrolment ratio (%) in Cote d'Ivoire in 1973 to that in 1974?
Offer a very short reply. 1.03. What is the ratio of the Gross enrolment ratio (%) in El Salvador in 1973 to that in 1974?
Keep it short and to the point. 0.85. What is the ratio of the Gross enrolment ratio (%) in Niger in 1973 to that in 1974?
Keep it short and to the point. 0.85. What is the ratio of the Gross enrolment ratio (%) in Vanuatu in 1973 to that in 1974?
Make the answer very short. 0.88. What is the ratio of the Gross enrolment ratio (%) of Cote d'Ivoire in 1973 to that in 1975?
Your response must be concise. 0.98. What is the ratio of the Gross enrolment ratio (%) in El Salvador in 1973 to that in 1975?
Keep it short and to the point. 0.79. What is the ratio of the Gross enrolment ratio (%) in Niger in 1973 to that in 1975?
Offer a terse response. 0.8. What is the ratio of the Gross enrolment ratio (%) in Vanuatu in 1973 to that in 1975?
Provide a short and direct response. 0.78. What is the ratio of the Gross enrolment ratio (%) in Cote d'Ivoire in 1973 to that in 1976?
Give a very brief answer. 0.9. What is the ratio of the Gross enrolment ratio (%) in El Salvador in 1973 to that in 1976?
Offer a terse response. 0.74. What is the ratio of the Gross enrolment ratio (%) in Niger in 1973 to that in 1976?
Your answer should be very brief. 0.7. What is the ratio of the Gross enrolment ratio (%) of Vanuatu in 1973 to that in 1976?
Ensure brevity in your answer.  0.68. What is the ratio of the Gross enrolment ratio (%) of Cote d'Ivoire in 1973 to that in 1977?
Give a very brief answer. 0.88. What is the ratio of the Gross enrolment ratio (%) in El Salvador in 1973 to that in 1977?
Your response must be concise. 0.72. What is the ratio of the Gross enrolment ratio (%) in Niger in 1973 to that in 1977?
Your answer should be compact. 0.57. What is the ratio of the Gross enrolment ratio (%) in Vanuatu in 1973 to that in 1977?
Ensure brevity in your answer.  0.59. What is the ratio of the Gross enrolment ratio (%) of Cote d'Ivoire in 1973 to that in 1978?
Your answer should be very brief. 0.82. What is the ratio of the Gross enrolment ratio (%) of El Salvador in 1973 to that in 1978?
Your response must be concise. 0.68. What is the ratio of the Gross enrolment ratio (%) of Niger in 1973 to that in 1978?
Your answer should be very brief. 0.47. What is the ratio of the Gross enrolment ratio (%) in Vanuatu in 1973 to that in 1978?
Provide a succinct answer. 0.57. What is the ratio of the Gross enrolment ratio (%) in Cote d'Ivoire in 1973 to that in 1980?
Keep it short and to the point. 0.68. What is the ratio of the Gross enrolment ratio (%) in El Salvador in 1973 to that in 1980?
Your response must be concise. 0.71. What is the ratio of the Gross enrolment ratio (%) in Niger in 1973 to that in 1980?
Your answer should be very brief. 0.33. What is the ratio of the Gross enrolment ratio (%) of Vanuatu in 1973 to that in 1980?
Your response must be concise. 0.57. What is the ratio of the Gross enrolment ratio (%) of Cote d'Ivoire in 1974 to that in 1975?
Provide a short and direct response. 0.95. What is the ratio of the Gross enrolment ratio (%) of El Salvador in 1974 to that in 1975?
Your answer should be compact. 0.93. What is the ratio of the Gross enrolment ratio (%) of Niger in 1974 to that in 1975?
Your response must be concise. 0.93. What is the ratio of the Gross enrolment ratio (%) of Vanuatu in 1974 to that in 1975?
Keep it short and to the point. 0.9. What is the ratio of the Gross enrolment ratio (%) in Cote d'Ivoire in 1974 to that in 1976?
Offer a terse response. 0.87. What is the ratio of the Gross enrolment ratio (%) of El Salvador in 1974 to that in 1976?
Your answer should be very brief. 0.87. What is the ratio of the Gross enrolment ratio (%) in Niger in 1974 to that in 1976?
Provide a short and direct response. 0.82. What is the ratio of the Gross enrolment ratio (%) in Vanuatu in 1974 to that in 1976?
Offer a terse response. 0.78. What is the ratio of the Gross enrolment ratio (%) in Cote d'Ivoire in 1974 to that in 1977?
Ensure brevity in your answer.  0.85. What is the ratio of the Gross enrolment ratio (%) of El Salvador in 1974 to that in 1977?
Provide a short and direct response. 0.84. What is the ratio of the Gross enrolment ratio (%) of Niger in 1974 to that in 1977?
Ensure brevity in your answer.  0.66. What is the ratio of the Gross enrolment ratio (%) in Vanuatu in 1974 to that in 1977?
Offer a very short reply. 0.68. What is the ratio of the Gross enrolment ratio (%) in Cote d'Ivoire in 1974 to that in 1978?
Offer a terse response. 0.79. What is the ratio of the Gross enrolment ratio (%) of El Salvador in 1974 to that in 1978?
Provide a short and direct response. 0.8. What is the ratio of the Gross enrolment ratio (%) of Niger in 1974 to that in 1978?
Provide a short and direct response. 0.54. What is the ratio of the Gross enrolment ratio (%) of Vanuatu in 1974 to that in 1978?
Make the answer very short. 0.65. What is the ratio of the Gross enrolment ratio (%) in Cote d'Ivoire in 1974 to that in 1980?
Provide a succinct answer. 0.65. What is the ratio of the Gross enrolment ratio (%) of El Salvador in 1974 to that in 1980?
Offer a very short reply. 0.84. What is the ratio of the Gross enrolment ratio (%) in Niger in 1974 to that in 1980?
Your response must be concise. 0.39. What is the ratio of the Gross enrolment ratio (%) in Vanuatu in 1974 to that in 1980?
Your response must be concise. 0.65. What is the ratio of the Gross enrolment ratio (%) of El Salvador in 1975 to that in 1976?
Your answer should be very brief. 0.93. What is the ratio of the Gross enrolment ratio (%) of Niger in 1975 to that in 1976?
Ensure brevity in your answer.  0.89. What is the ratio of the Gross enrolment ratio (%) in Vanuatu in 1975 to that in 1976?
Provide a succinct answer. 0.87. What is the ratio of the Gross enrolment ratio (%) of Cote d'Ivoire in 1975 to that in 1977?
Offer a terse response. 0.89. What is the ratio of the Gross enrolment ratio (%) of El Salvador in 1975 to that in 1977?
Your response must be concise. 0.9. What is the ratio of the Gross enrolment ratio (%) in Niger in 1975 to that in 1977?
Your answer should be compact. 0.71. What is the ratio of the Gross enrolment ratio (%) in Vanuatu in 1975 to that in 1977?
Offer a terse response. 0.76. What is the ratio of the Gross enrolment ratio (%) of Cote d'Ivoire in 1975 to that in 1978?
Offer a very short reply. 0.83. What is the ratio of the Gross enrolment ratio (%) of El Salvador in 1975 to that in 1978?
Ensure brevity in your answer.  0.85. What is the ratio of the Gross enrolment ratio (%) in Niger in 1975 to that in 1978?
Your response must be concise. 0.58. What is the ratio of the Gross enrolment ratio (%) of Vanuatu in 1975 to that in 1978?
Offer a very short reply. 0.73. What is the ratio of the Gross enrolment ratio (%) of Cote d'Ivoire in 1975 to that in 1980?
Ensure brevity in your answer.  0.69. What is the ratio of the Gross enrolment ratio (%) of El Salvador in 1975 to that in 1980?
Your response must be concise. 0.9. What is the ratio of the Gross enrolment ratio (%) of Niger in 1975 to that in 1980?
Provide a short and direct response. 0.42. What is the ratio of the Gross enrolment ratio (%) in Vanuatu in 1975 to that in 1980?
Offer a terse response. 0.72. What is the ratio of the Gross enrolment ratio (%) of Cote d'Ivoire in 1976 to that in 1977?
Offer a terse response. 0.97. What is the ratio of the Gross enrolment ratio (%) of El Salvador in 1976 to that in 1977?
Make the answer very short. 0.97. What is the ratio of the Gross enrolment ratio (%) of Niger in 1976 to that in 1977?
Your answer should be compact. 0.8. What is the ratio of the Gross enrolment ratio (%) of Vanuatu in 1976 to that in 1977?
Your response must be concise. 0.87. What is the ratio of the Gross enrolment ratio (%) of Cote d'Ivoire in 1976 to that in 1978?
Provide a succinct answer. 0.91. What is the ratio of the Gross enrolment ratio (%) of El Salvador in 1976 to that in 1978?
Your response must be concise. 0.92. What is the ratio of the Gross enrolment ratio (%) of Niger in 1976 to that in 1978?
Your answer should be compact. 0.66. What is the ratio of the Gross enrolment ratio (%) of Vanuatu in 1976 to that in 1978?
Give a very brief answer. 0.83. What is the ratio of the Gross enrolment ratio (%) of Cote d'Ivoire in 1976 to that in 1980?
Your answer should be compact. 0.75. What is the ratio of the Gross enrolment ratio (%) in El Salvador in 1976 to that in 1980?
Your answer should be compact. 0.97. What is the ratio of the Gross enrolment ratio (%) of Niger in 1976 to that in 1980?
Offer a very short reply. 0.47. What is the ratio of the Gross enrolment ratio (%) in Vanuatu in 1976 to that in 1980?
Offer a very short reply. 0.83. What is the ratio of the Gross enrolment ratio (%) of Cote d'Ivoire in 1977 to that in 1978?
Your response must be concise. 0.93. What is the ratio of the Gross enrolment ratio (%) of El Salvador in 1977 to that in 1978?
Give a very brief answer. 0.95. What is the ratio of the Gross enrolment ratio (%) in Niger in 1977 to that in 1978?
Provide a short and direct response. 0.82. What is the ratio of the Gross enrolment ratio (%) of Vanuatu in 1977 to that in 1978?
Offer a terse response. 0.96. What is the ratio of the Gross enrolment ratio (%) in Cote d'Ivoire in 1977 to that in 1980?
Ensure brevity in your answer.  0.77. What is the ratio of the Gross enrolment ratio (%) in Niger in 1977 to that in 1980?
Make the answer very short. 0.59. What is the ratio of the Gross enrolment ratio (%) of Vanuatu in 1977 to that in 1980?
Keep it short and to the point. 0.95. What is the ratio of the Gross enrolment ratio (%) of Cote d'Ivoire in 1978 to that in 1980?
Offer a terse response. 0.83. What is the ratio of the Gross enrolment ratio (%) in El Salvador in 1978 to that in 1980?
Ensure brevity in your answer.  1.05. What is the ratio of the Gross enrolment ratio (%) in Niger in 1978 to that in 1980?
Your response must be concise. 0.71. What is the ratio of the Gross enrolment ratio (%) of Vanuatu in 1978 to that in 1980?
Your answer should be compact. 0.99. What is the difference between the highest and the second highest Gross enrolment ratio (%) of Cote d'Ivoire?
Keep it short and to the point. 3.1. What is the difference between the highest and the second highest Gross enrolment ratio (%) of El Salvador?
Keep it short and to the point. 1.78. What is the difference between the highest and the second highest Gross enrolment ratio (%) in Niger?
Offer a very short reply. 1.16. What is the difference between the highest and the second highest Gross enrolment ratio (%) in Vanuatu?
Keep it short and to the point. 0.1. What is the difference between the highest and the lowest Gross enrolment ratio (%) in Cote d'Ivoire?
Keep it short and to the point. 6.24. What is the difference between the highest and the lowest Gross enrolment ratio (%) of El Salvador?
Make the answer very short. 11.08. What is the difference between the highest and the lowest Gross enrolment ratio (%) in Niger?
Your response must be concise. 2.71. What is the difference between the highest and the lowest Gross enrolment ratio (%) of Vanuatu?
Your answer should be compact. 5.5. 